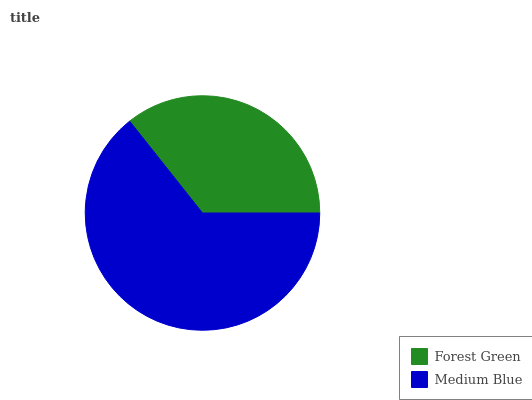Is Forest Green the minimum?
Answer yes or no. Yes. Is Medium Blue the maximum?
Answer yes or no. Yes. Is Medium Blue the minimum?
Answer yes or no. No. Is Medium Blue greater than Forest Green?
Answer yes or no. Yes. Is Forest Green less than Medium Blue?
Answer yes or no. Yes. Is Forest Green greater than Medium Blue?
Answer yes or no. No. Is Medium Blue less than Forest Green?
Answer yes or no. No. Is Medium Blue the high median?
Answer yes or no. Yes. Is Forest Green the low median?
Answer yes or no. Yes. Is Forest Green the high median?
Answer yes or no. No. Is Medium Blue the low median?
Answer yes or no. No. 